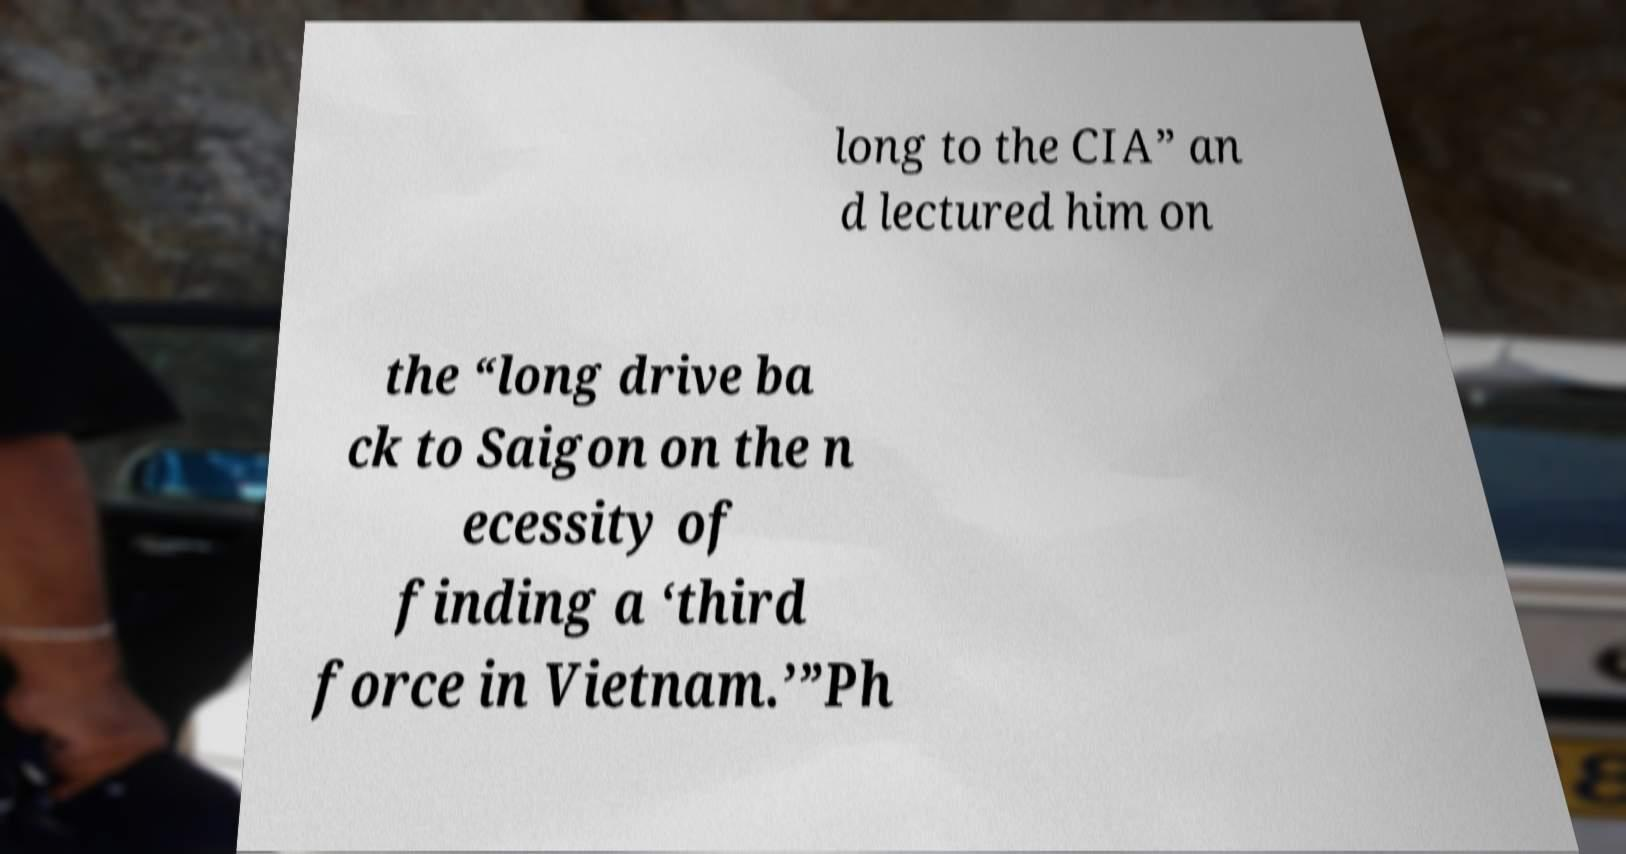What messages or text are displayed in this image? I need them in a readable, typed format. long to the CIA” an d lectured him on the “long drive ba ck to Saigon on the n ecessity of finding a ‘third force in Vietnam.’”Ph 